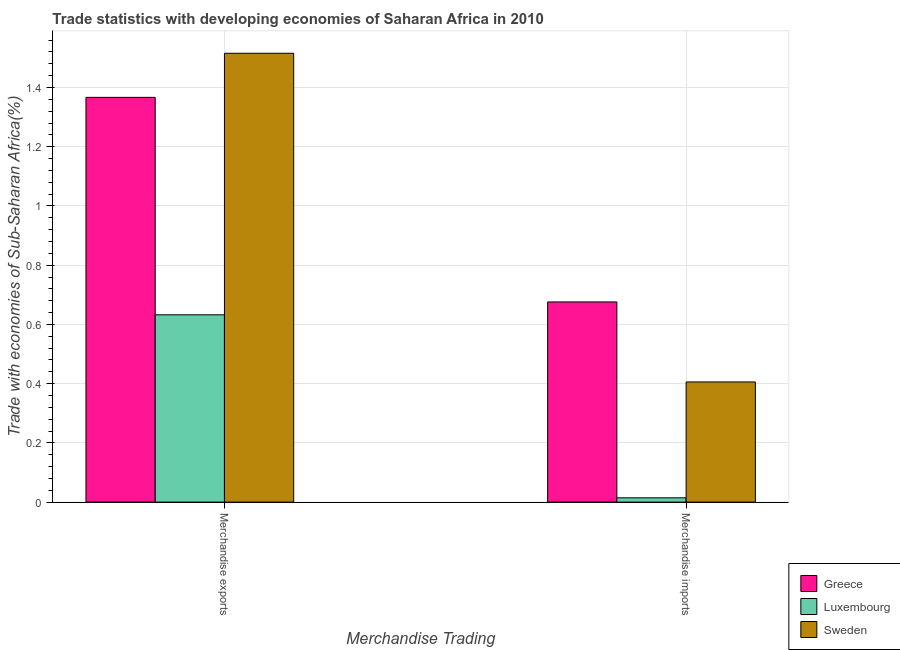How many different coloured bars are there?
Give a very brief answer. 3. How many groups of bars are there?
Provide a succinct answer. 2. Are the number of bars on each tick of the X-axis equal?
Give a very brief answer. Yes. How many bars are there on the 1st tick from the left?
Your answer should be very brief. 3. What is the label of the 2nd group of bars from the left?
Your answer should be compact. Merchandise imports. What is the merchandise exports in Greece?
Provide a succinct answer. 1.37. Across all countries, what is the maximum merchandise exports?
Offer a terse response. 1.52. Across all countries, what is the minimum merchandise exports?
Offer a very short reply. 0.63. In which country was the merchandise imports maximum?
Make the answer very short. Greece. In which country was the merchandise imports minimum?
Your answer should be compact. Luxembourg. What is the total merchandise imports in the graph?
Your answer should be compact. 1.1. What is the difference between the merchandise imports in Luxembourg and that in Sweden?
Make the answer very short. -0.39. What is the difference between the merchandise exports in Sweden and the merchandise imports in Luxembourg?
Provide a short and direct response. 1.5. What is the average merchandise imports per country?
Keep it short and to the point. 0.37. What is the difference between the merchandise imports and merchandise exports in Sweden?
Your answer should be compact. -1.11. In how many countries, is the merchandise exports greater than 1.2800000000000002 %?
Offer a terse response. 2. What is the ratio of the merchandise exports in Greece to that in Sweden?
Keep it short and to the point. 0.9. In how many countries, is the merchandise exports greater than the average merchandise exports taken over all countries?
Offer a very short reply. 2. What does the 1st bar from the right in Merchandise exports represents?
Your response must be concise. Sweden. How many bars are there?
Offer a very short reply. 6. How many countries are there in the graph?
Your response must be concise. 3. What is the difference between two consecutive major ticks on the Y-axis?
Offer a very short reply. 0.2. Does the graph contain grids?
Keep it short and to the point. Yes. What is the title of the graph?
Make the answer very short. Trade statistics with developing economies of Saharan Africa in 2010. Does "Dominica" appear as one of the legend labels in the graph?
Provide a short and direct response. No. What is the label or title of the X-axis?
Your answer should be very brief. Merchandise Trading. What is the label or title of the Y-axis?
Offer a terse response. Trade with economies of Sub-Saharan Africa(%). What is the Trade with economies of Sub-Saharan Africa(%) in Greece in Merchandise exports?
Your response must be concise. 1.37. What is the Trade with economies of Sub-Saharan Africa(%) in Luxembourg in Merchandise exports?
Offer a terse response. 0.63. What is the Trade with economies of Sub-Saharan Africa(%) in Sweden in Merchandise exports?
Keep it short and to the point. 1.52. What is the Trade with economies of Sub-Saharan Africa(%) in Greece in Merchandise imports?
Your response must be concise. 0.68. What is the Trade with economies of Sub-Saharan Africa(%) in Luxembourg in Merchandise imports?
Your response must be concise. 0.01. What is the Trade with economies of Sub-Saharan Africa(%) in Sweden in Merchandise imports?
Give a very brief answer. 0.41. Across all Merchandise Trading, what is the maximum Trade with economies of Sub-Saharan Africa(%) in Greece?
Keep it short and to the point. 1.37. Across all Merchandise Trading, what is the maximum Trade with economies of Sub-Saharan Africa(%) in Luxembourg?
Ensure brevity in your answer.  0.63. Across all Merchandise Trading, what is the maximum Trade with economies of Sub-Saharan Africa(%) in Sweden?
Your response must be concise. 1.52. Across all Merchandise Trading, what is the minimum Trade with economies of Sub-Saharan Africa(%) in Greece?
Provide a succinct answer. 0.68. Across all Merchandise Trading, what is the minimum Trade with economies of Sub-Saharan Africa(%) of Luxembourg?
Make the answer very short. 0.01. Across all Merchandise Trading, what is the minimum Trade with economies of Sub-Saharan Africa(%) in Sweden?
Offer a very short reply. 0.41. What is the total Trade with economies of Sub-Saharan Africa(%) of Greece in the graph?
Provide a short and direct response. 2.04. What is the total Trade with economies of Sub-Saharan Africa(%) in Luxembourg in the graph?
Offer a terse response. 0.65. What is the total Trade with economies of Sub-Saharan Africa(%) of Sweden in the graph?
Provide a succinct answer. 1.92. What is the difference between the Trade with economies of Sub-Saharan Africa(%) of Greece in Merchandise exports and that in Merchandise imports?
Keep it short and to the point. 0.69. What is the difference between the Trade with economies of Sub-Saharan Africa(%) in Luxembourg in Merchandise exports and that in Merchandise imports?
Ensure brevity in your answer.  0.62. What is the difference between the Trade with economies of Sub-Saharan Africa(%) of Sweden in Merchandise exports and that in Merchandise imports?
Your answer should be compact. 1.11. What is the difference between the Trade with economies of Sub-Saharan Africa(%) in Greece in Merchandise exports and the Trade with economies of Sub-Saharan Africa(%) in Luxembourg in Merchandise imports?
Provide a succinct answer. 1.35. What is the difference between the Trade with economies of Sub-Saharan Africa(%) of Greece in Merchandise exports and the Trade with economies of Sub-Saharan Africa(%) of Sweden in Merchandise imports?
Provide a succinct answer. 0.96. What is the difference between the Trade with economies of Sub-Saharan Africa(%) of Luxembourg in Merchandise exports and the Trade with economies of Sub-Saharan Africa(%) of Sweden in Merchandise imports?
Provide a succinct answer. 0.23. What is the average Trade with economies of Sub-Saharan Africa(%) in Greece per Merchandise Trading?
Provide a short and direct response. 1.02. What is the average Trade with economies of Sub-Saharan Africa(%) of Luxembourg per Merchandise Trading?
Provide a succinct answer. 0.32. What is the average Trade with economies of Sub-Saharan Africa(%) of Sweden per Merchandise Trading?
Your response must be concise. 0.96. What is the difference between the Trade with economies of Sub-Saharan Africa(%) of Greece and Trade with economies of Sub-Saharan Africa(%) of Luxembourg in Merchandise exports?
Offer a very short reply. 0.73. What is the difference between the Trade with economies of Sub-Saharan Africa(%) in Greece and Trade with economies of Sub-Saharan Africa(%) in Sweden in Merchandise exports?
Your response must be concise. -0.15. What is the difference between the Trade with economies of Sub-Saharan Africa(%) in Luxembourg and Trade with economies of Sub-Saharan Africa(%) in Sweden in Merchandise exports?
Offer a very short reply. -0.88. What is the difference between the Trade with economies of Sub-Saharan Africa(%) of Greece and Trade with economies of Sub-Saharan Africa(%) of Luxembourg in Merchandise imports?
Give a very brief answer. 0.66. What is the difference between the Trade with economies of Sub-Saharan Africa(%) of Greece and Trade with economies of Sub-Saharan Africa(%) of Sweden in Merchandise imports?
Offer a very short reply. 0.27. What is the difference between the Trade with economies of Sub-Saharan Africa(%) of Luxembourg and Trade with economies of Sub-Saharan Africa(%) of Sweden in Merchandise imports?
Your answer should be very brief. -0.39. What is the ratio of the Trade with economies of Sub-Saharan Africa(%) of Greece in Merchandise exports to that in Merchandise imports?
Offer a very short reply. 2.02. What is the ratio of the Trade with economies of Sub-Saharan Africa(%) of Luxembourg in Merchandise exports to that in Merchandise imports?
Your response must be concise. 43.57. What is the ratio of the Trade with economies of Sub-Saharan Africa(%) in Sweden in Merchandise exports to that in Merchandise imports?
Your answer should be very brief. 3.74. What is the difference between the highest and the second highest Trade with economies of Sub-Saharan Africa(%) in Greece?
Provide a short and direct response. 0.69. What is the difference between the highest and the second highest Trade with economies of Sub-Saharan Africa(%) in Luxembourg?
Your response must be concise. 0.62. What is the difference between the highest and the second highest Trade with economies of Sub-Saharan Africa(%) in Sweden?
Your answer should be very brief. 1.11. What is the difference between the highest and the lowest Trade with economies of Sub-Saharan Africa(%) in Greece?
Your answer should be very brief. 0.69. What is the difference between the highest and the lowest Trade with economies of Sub-Saharan Africa(%) in Luxembourg?
Offer a terse response. 0.62. What is the difference between the highest and the lowest Trade with economies of Sub-Saharan Africa(%) of Sweden?
Give a very brief answer. 1.11. 